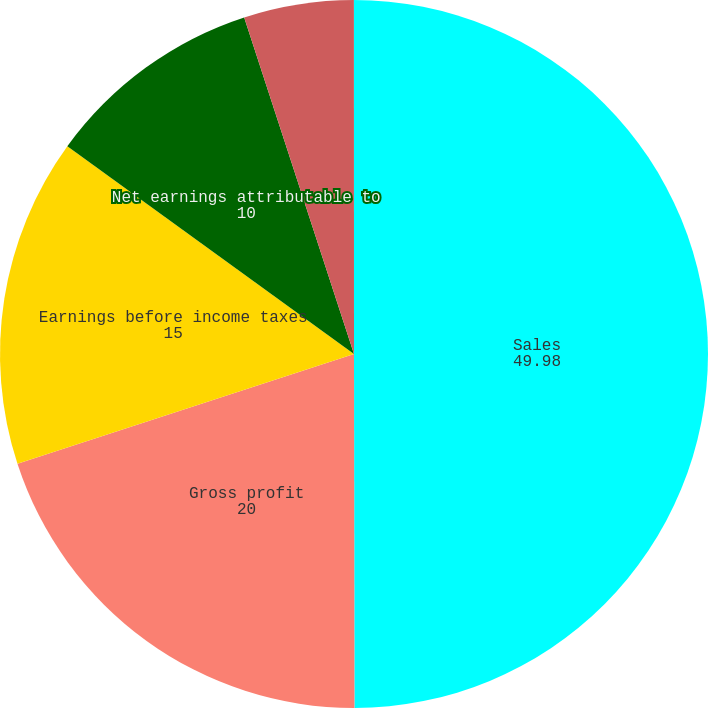<chart> <loc_0><loc_0><loc_500><loc_500><pie_chart><fcel>Sales<fcel>Gross profit<fcel>Earnings before income taxes<fcel>Net earnings attributable to<fcel>Basic<fcel>Diluted<nl><fcel>49.98%<fcel>20.0%<fcel>15.0%<fcel>10.0%<fcel>5.01%<fcel>0.01%<nl></chart> 